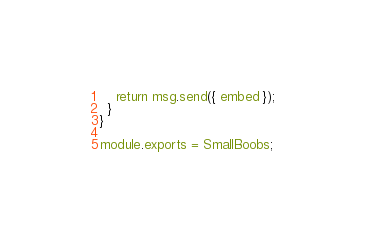<code> <loc_0><loc_0><loc_500><loc_500><_JavaScript_>
    return msg.send({ embed });
  }
}

module.exports = SmallBoobs;
</code> 